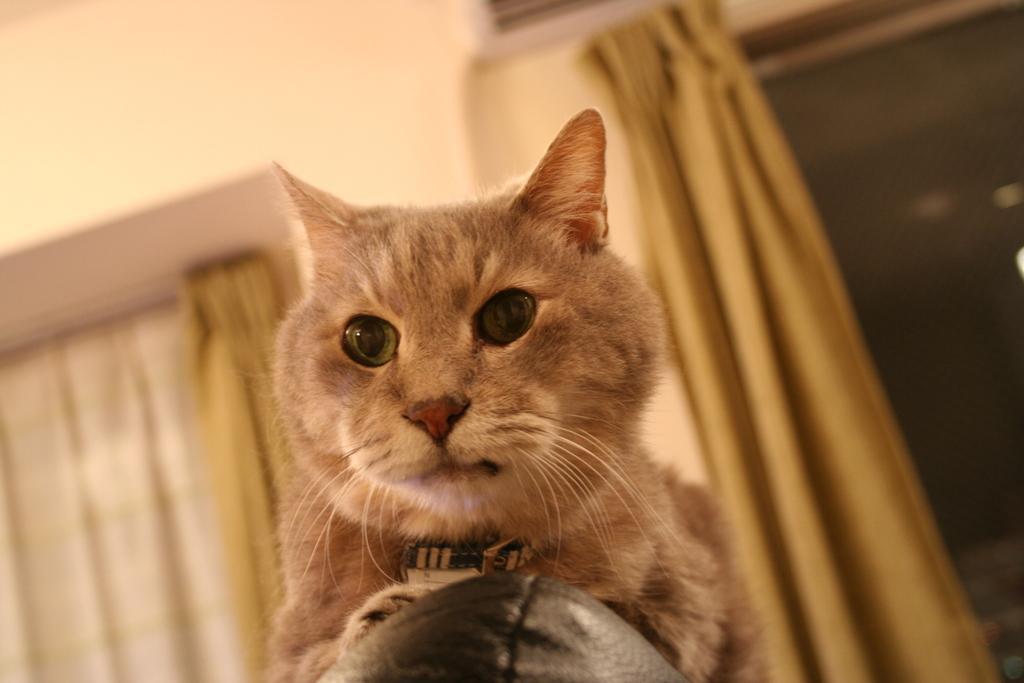In one or two sentences, can you explain what this image depicts? This picture is clicked inside the room. In the foreground we can see the cat and a black color object. In the background we can see the wall, curtains, window and some other items. 